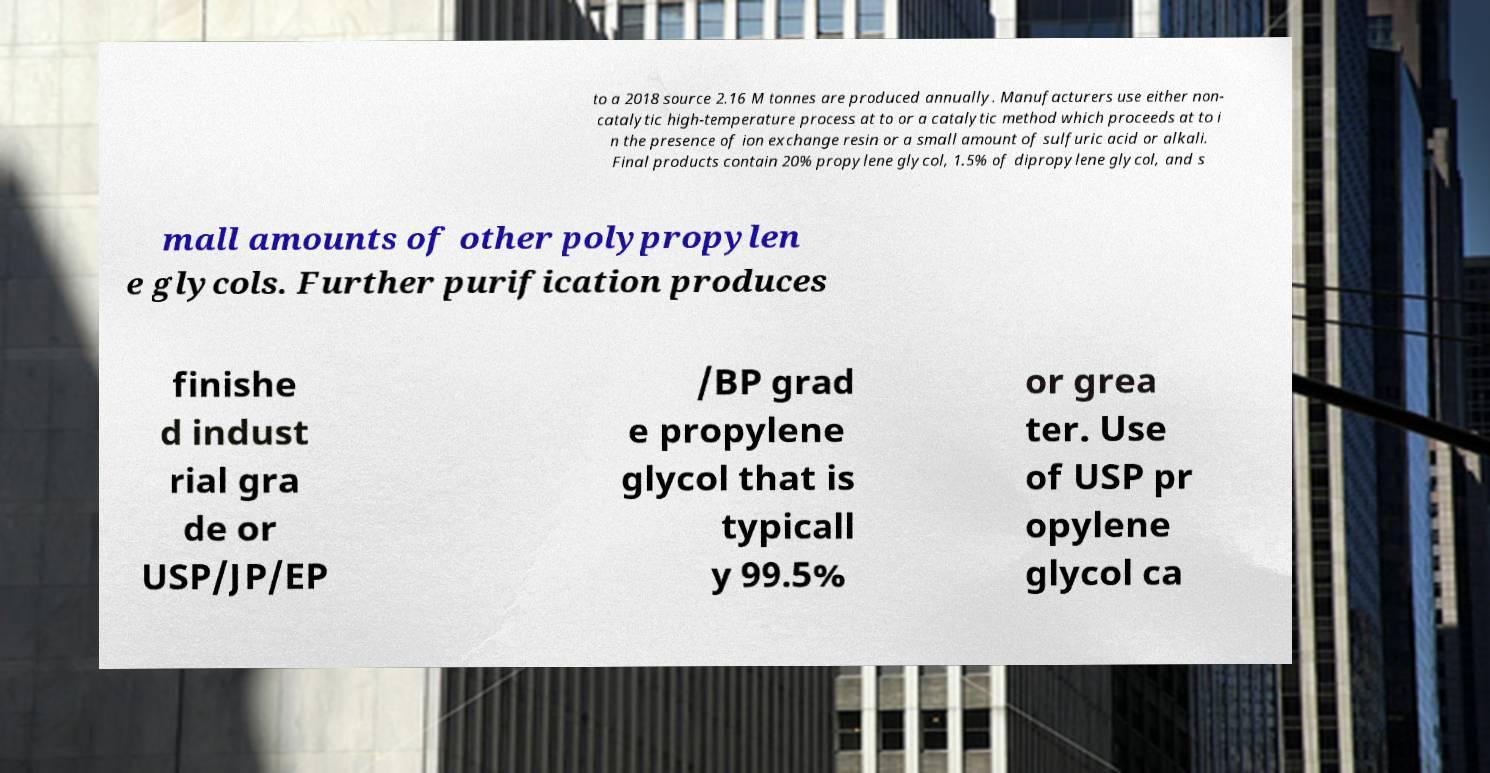Please identify and transcribe the text found in this image. to a 2018 source 2.16 M tonnes are produced annually. Manufacturers use either non- catalytic high-temperature process at to or a catalytic method which proceeds at to i n the presence of ion exchange resin or a small amount of sulfuric acid or alkali. Final products contain 20% propylene glycol, 1.5% of dipropylene glycol, and s mall amounts of other polypropylen e glycols. Further purification produces finishe d indust rial gra de or USP/JP/EP /BP grad e propylene glycol that is typicall y 99.5% or grea ter. Use of USP pr opylene glycol ca 